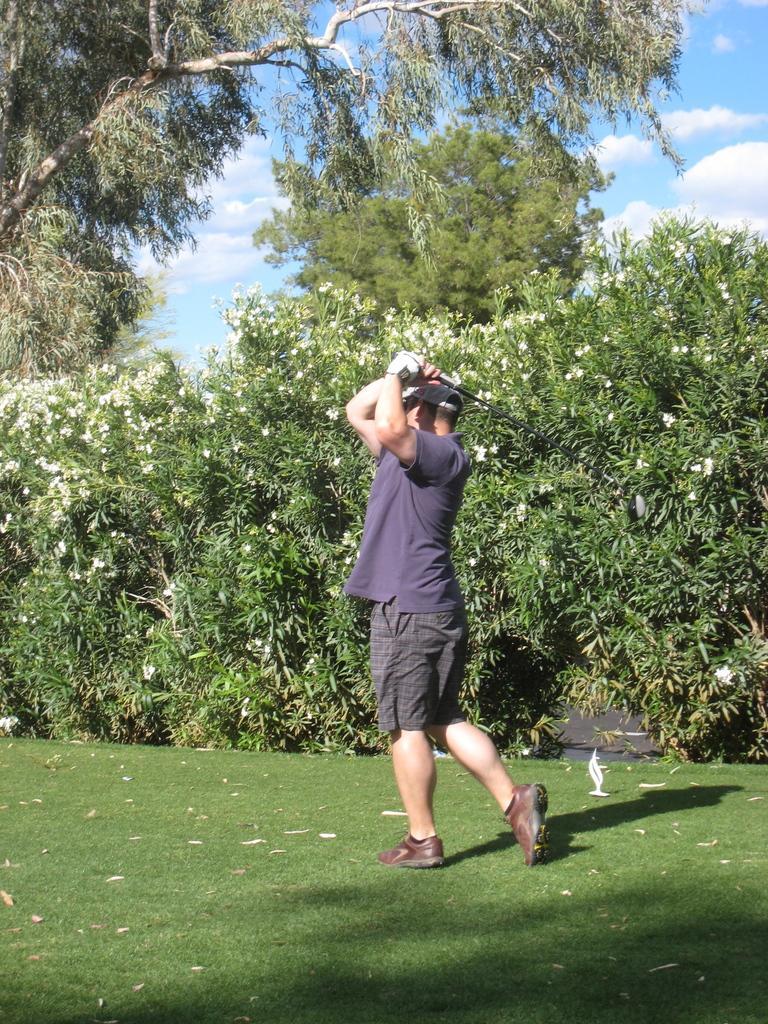Can you describe this image briefly? In this image there is a person holding an object, there is grass, there are trees, there is the sky, there are clouds in the sky, there are flowers, there is an object in the grass. 